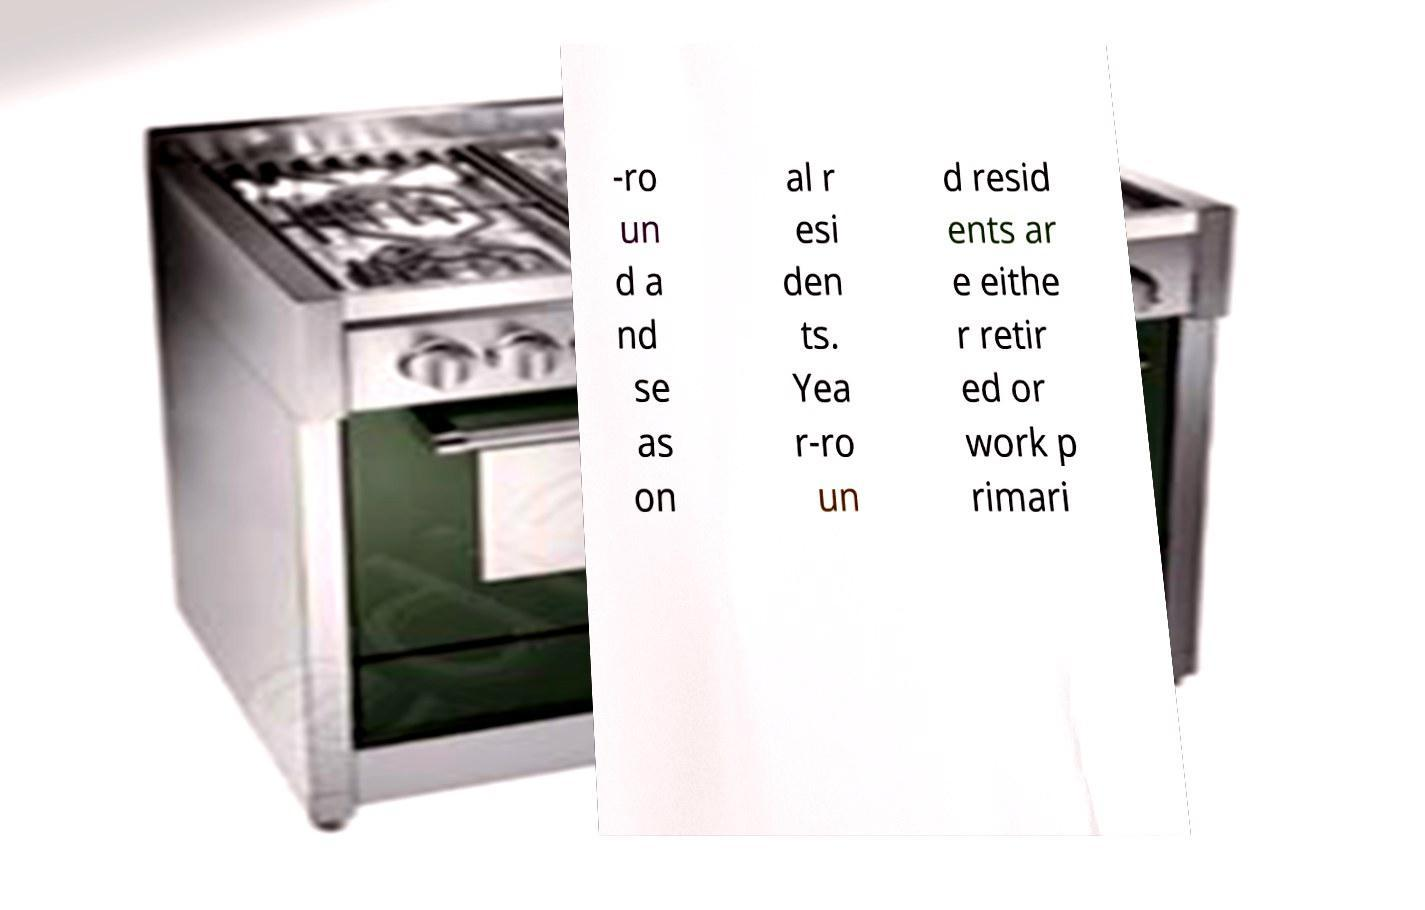There's text embedded in this image that I need extracted. Can you transcribe it verbatim? -ro un d a nd se as on al r esi den ts. Yea r-ro un d resid ents ar e eithe r retir ed or work p rimari 